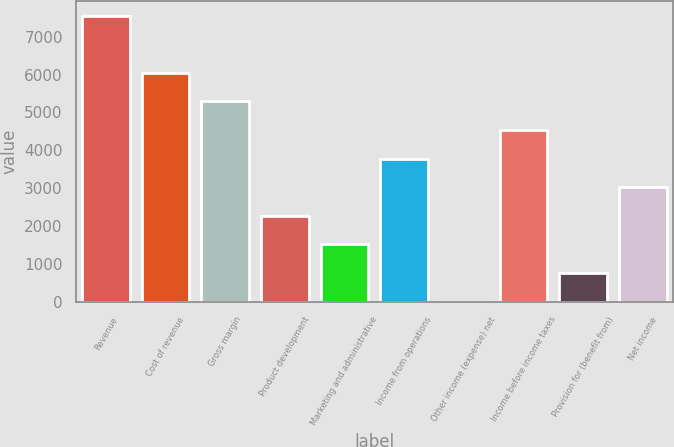Convert chart to OTSL. <chart><loc_0><loc_0><loc_500><loc_500><bar_chart><fcel>Revenue<fcel>Cost of revenue<fcel>Gross margin<fcel>Product development<fcel>Marketing and administrative<fcel>Income from operations<fcel>Other income (expense) net<fcel>Income before income taxes<fcel>Provision for (benefit from)<fcel>Net income<nl><fcel>7553<fcel>6044.4<fcel>5290.1<fcel>2272.9<fcel>1518.6<fcel>3781.5<fcel>10<fcel>4535.8<fcel>764.3<fcel>3027.2<nl></chart> 